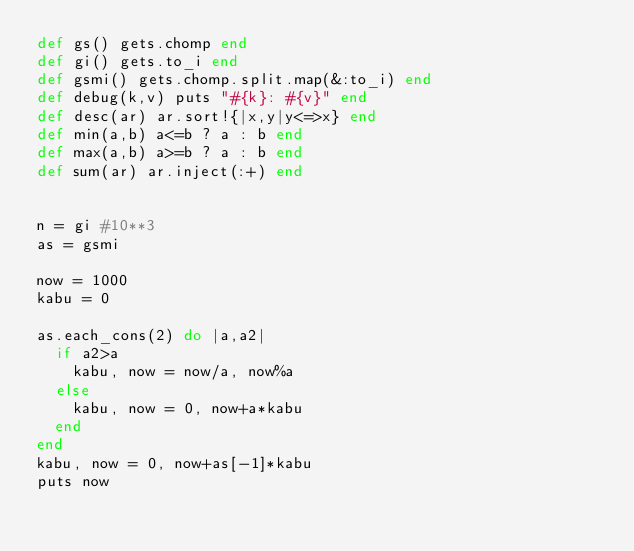<code> <loc_0><loc_0><loc_500><loc_500><_Ruby_>def gs() gets.chomp end
def gi() gets.to_i end
def gsmi() gets.chomp.split.map(&:to_i) end
def debug(k,v) puts "#{k}: #{v}" end
def desc(ar) ar.sort!{|x,y|y<=>x} end
def min(a,b) a<=b ? a : b end
def max(a,b) a>=b ? a : b end
def sum(ar) ar.inject(:+) end


n = gi #10**3
as = gsmi

now = 1000
kabu = 0

as.each_cons(2) do |a,a2|
  if a2>a
    kabu, now = now/a, now%a
  else
    kabu, now = 0, now+a*kabu
  end
end
kabu, now = 0, now+as[-1]*kabu
puts now
</code> 